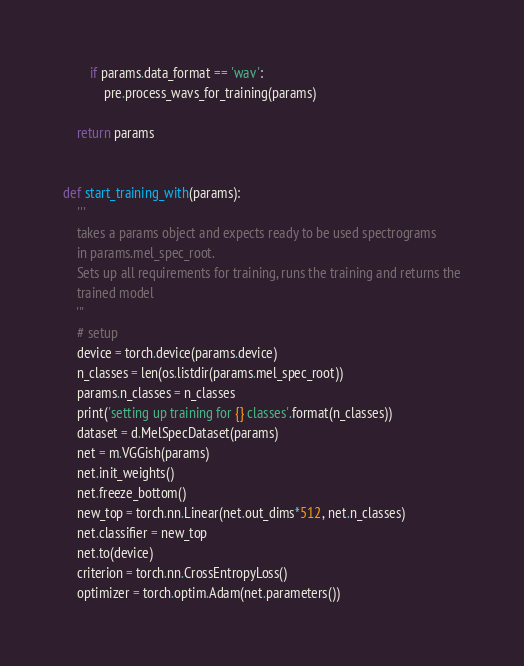<code> <loc_0><loc_0><loc_500><loc_500><_Python_>        if params.data_format == 'wav':
            pre.process_wavs_for_training(params)

    return params


def start_training_with(params):
    '''
    takes a params object and expects ready to be used spectrograms
    in params.mel_spec_root.
    Sets up all requirements for training, runs the training and returns the
    trained model
    '''
    # setup
    device = torch.device(params.device)
    n_classes = len(os.listdir(params.mel_spec_root))
    params.n_classes = n_classes
    print('setting up training for {} classes'.format(n_classes))
    dataset = d.MelSpecDataset(params)
    net = m.VGGish(params)
    net.init_weights()
    net.freeze_bottom()
    new_top = torch.nn.Linear(net.out_dims*512, net.n_classes)
    net.classifier = new_top
    net.to(device)
    criterion = torch.nn.CrossEntropyLoss()
    optimizer = torch.optim.Adam(net.parameters())</code> 